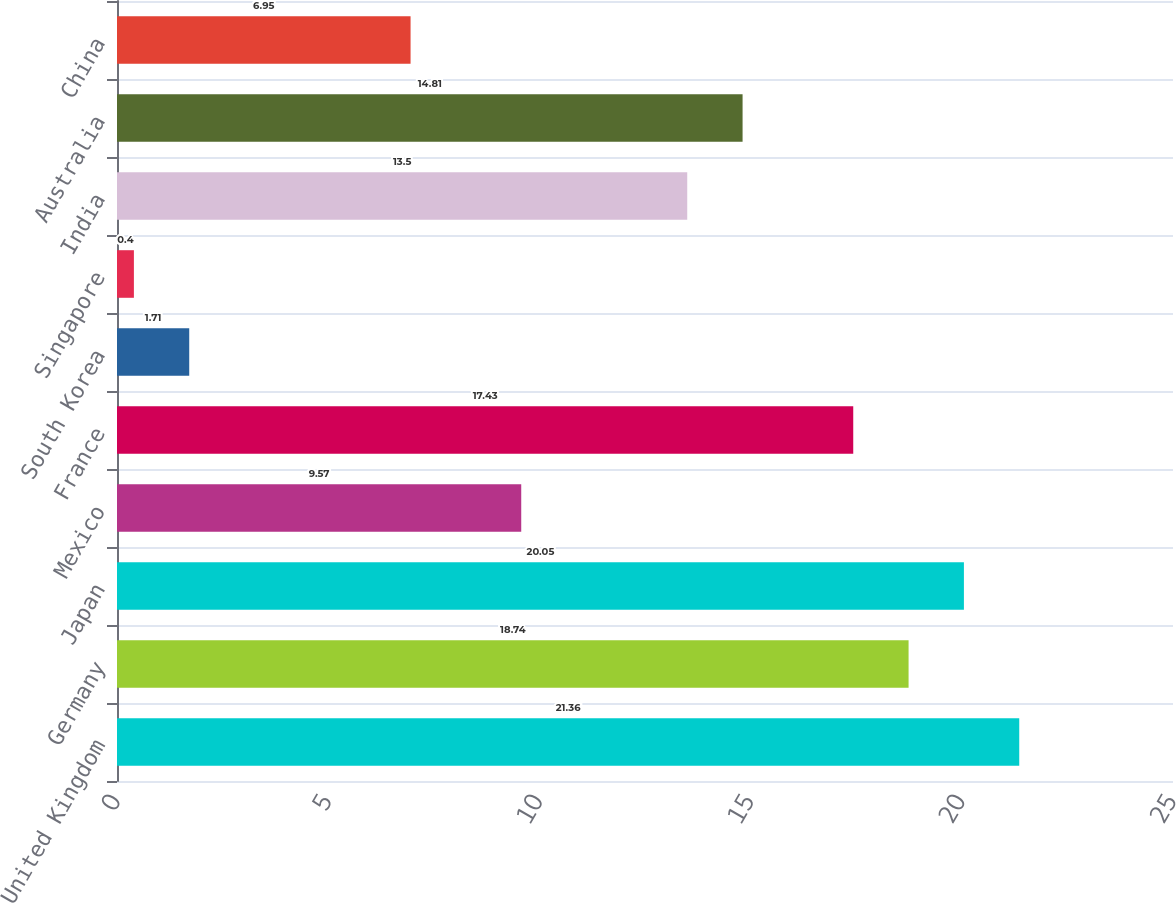Convert chart. <chart><loc_0><loc_0><loc_500><loc_500><bar_chart><fcel>United Kingdom<fcel>Germany<fcel>Japan<fcel>Mexico<fcel>France<fcel>South Korea<fcel>Singapore<fcel>India<fcel>Australia<fcel>China<nl><fcel>21.36<fcel>18.74<fcel>20.05<fcel>9.57<fcel>17.43<fcel>1.71<fcel>0.4<fcel>13.5<fcel>14.81<fcel>6.95<nl></chart> 